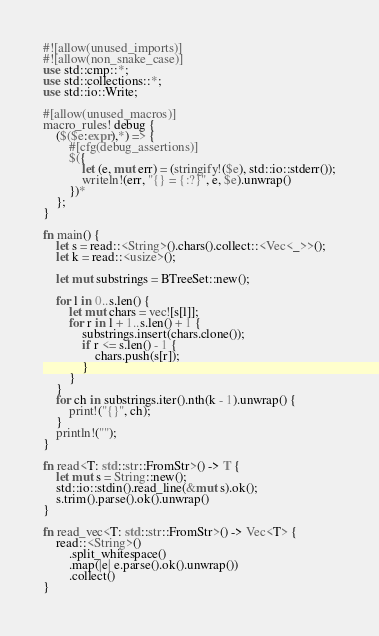Convert code to text. <code><loc_0><loc_0><loc_500><loc_500><_Rust_>#![allow(unused_imports)]
#![allow(non_snake_case)]
use std::cmp::*;
use std::collections::*;
use std::io::Write;

#[allow(unused_macros)]
macro_rules! debug {
    ($($e:expr),*) => {
        #[cfg(debug_assertions)]
        $({
            let (e, mut err) = (stringify!($e), std::io::stderr());
            writeln!(err, "{} = {:?}", e, $e).unwrap()
        })*
    };
}

fn main() {
    let s = read::<String>().chars().collect::<Vec<_>>();
    let k = read::<usize>();

    let mut substrings = BTreeSet::new();

    for l in 0..s.len() {
        let mut chars = vec![s[l]];
        for r in l + 1..s.len() + 1 {
            substrings.insert(chars.clone());
            if r <= s.len() - 1 {
                chars.push(s[r]);
            }
        }
    }
    for ch in substrings.iter().nth(k - 1).unwrap() {
        print!("{}", ch);
    }
    println!("");
}

fn read<T: std::str::FromStr>() -> T {
    let mut s = String::new();
    std::io::stdin().read_line(&mut s).ok();
    s.trim().parse().ok().unwrap()
}

fn read_vec<T: std::str::FromStr>() -> Vec<T> {
    read::<String>()
        .split_whitespace()
        .map(|e| e.parse().ok().unwrap())
        .collect()
}
</code> 